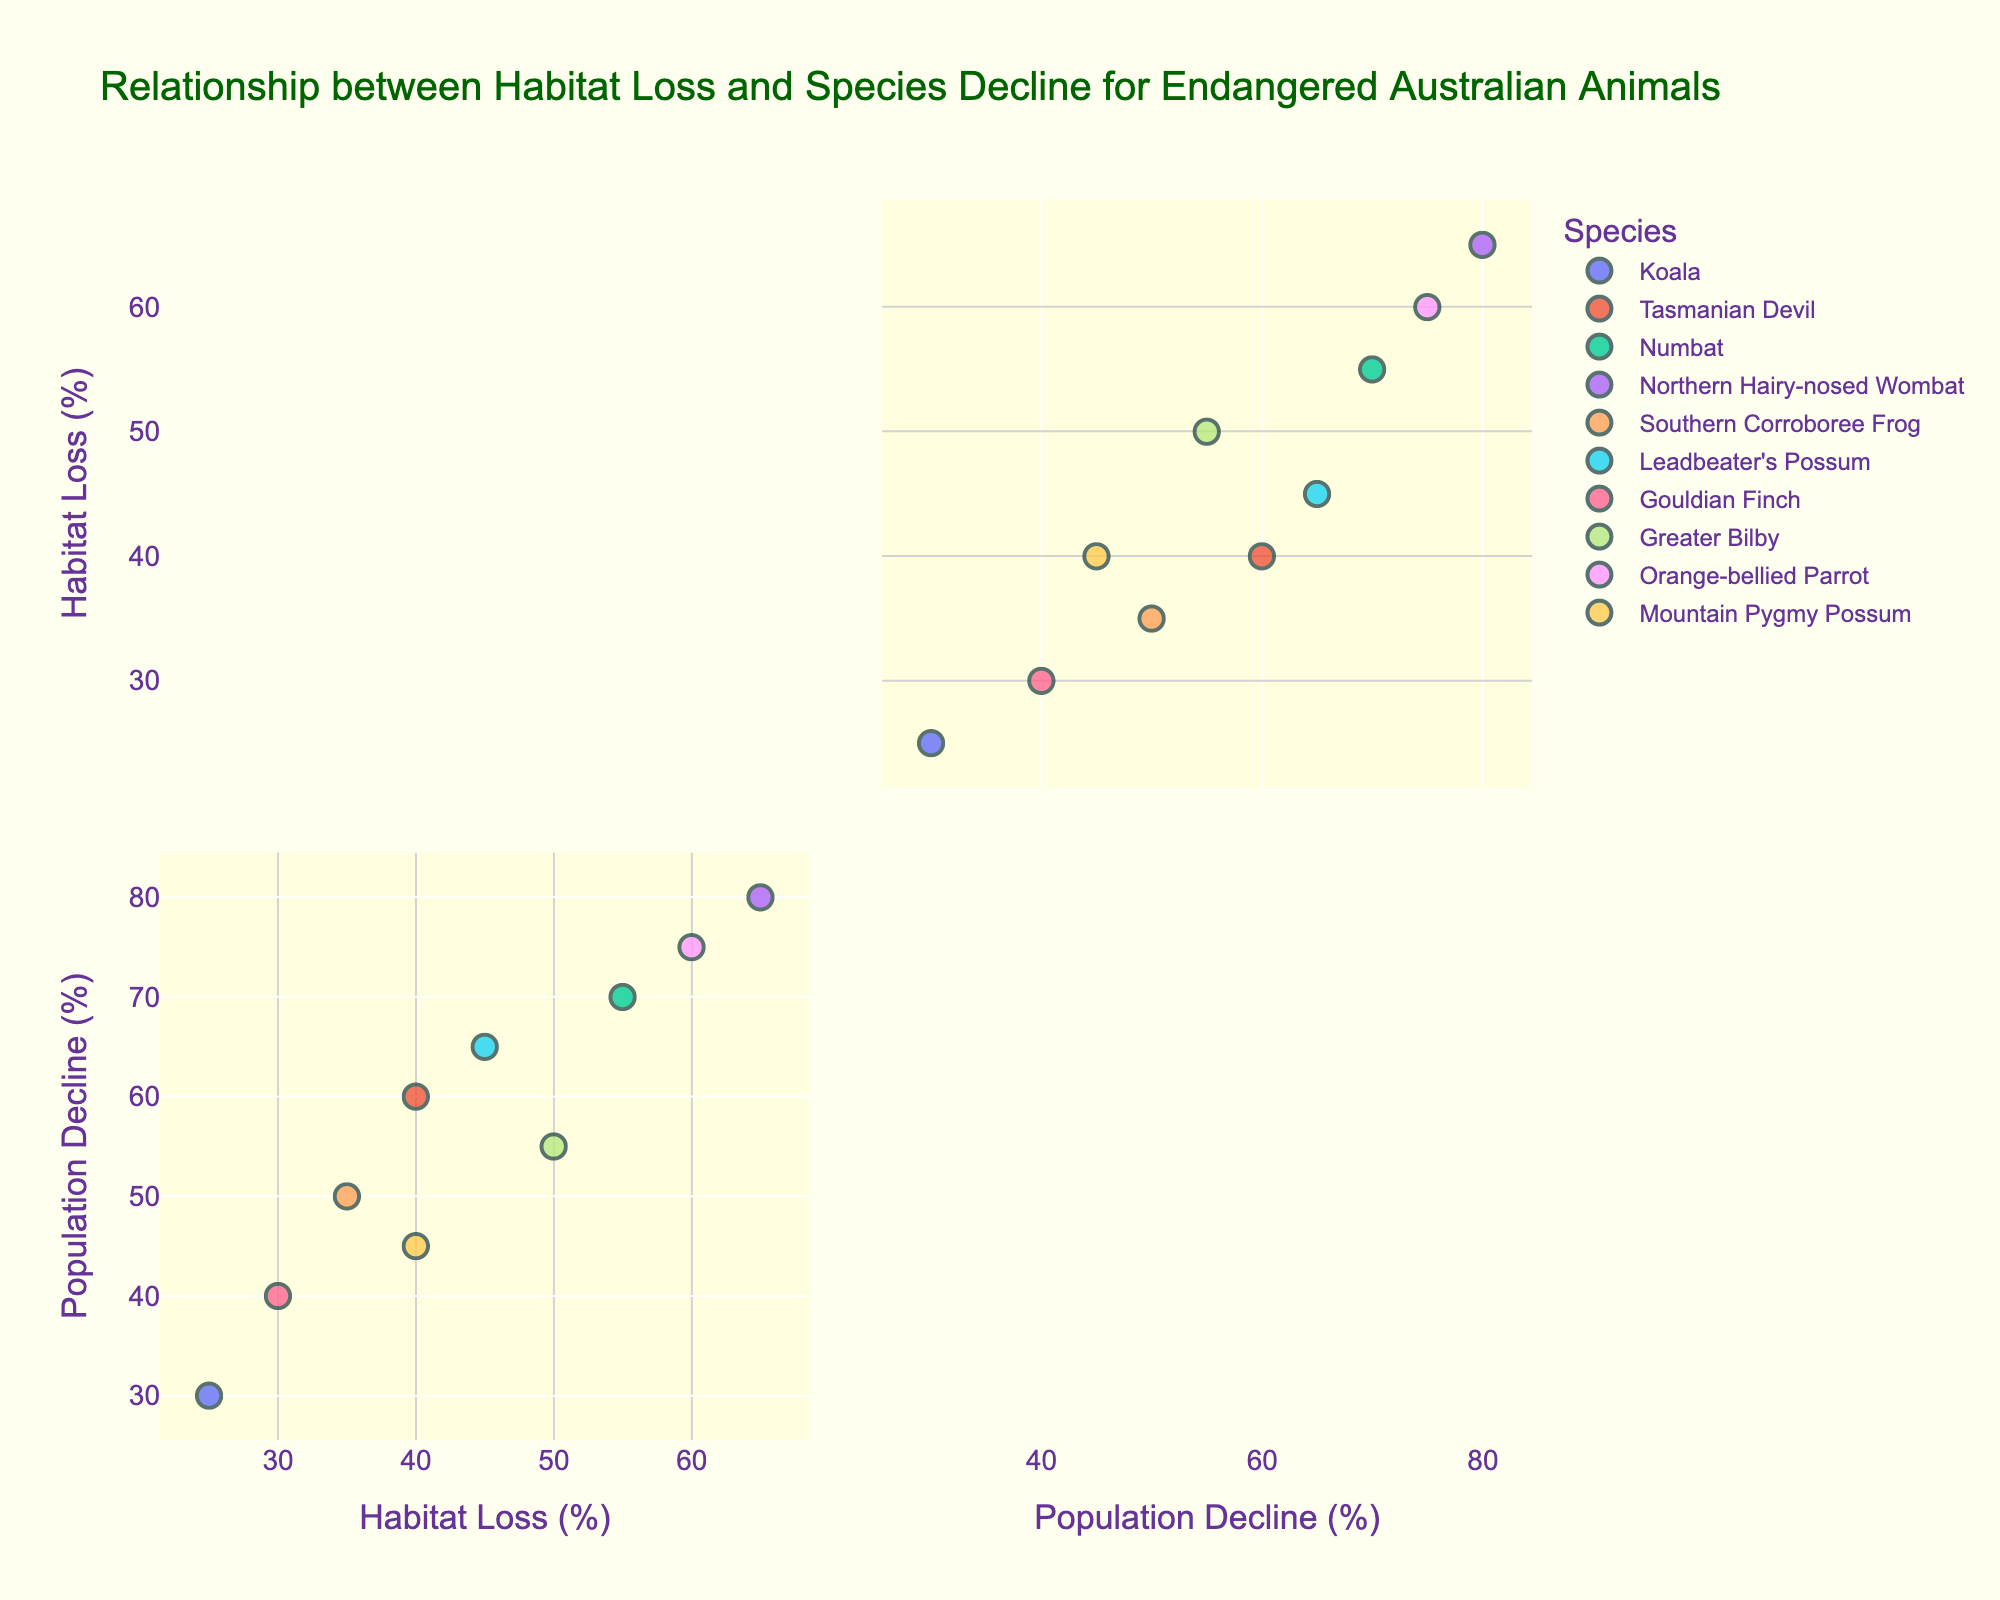What's the title of the scatterplot matrix? The title is usually displayed at the top of the figure. In this case, it reads "Relationship between Habitat Loss and Species Decline for Endangered Australian Animals."
Answer: Relationship between Habitat Loss and Species Decline for Endangered Australian Animals What are the axis labels in the scatterplot matrix? The axis labels can be found at the bottom and left of the scatterplot matrix. The x-axis label is "Habitat Loss (%)" and the y-axis label is "Population Decline (%)".
Answer: Habitat Loss (%) and Population Decline (%) How many species are represented in the scatterplot matrix? Each unique color represents a different species. By counting the unique colors in the legend, we see that there are 10 species.
Answer: 10 Which species shows the highest habitat loss percentage? Locate the species at the maximum point on the x-axis related to "Habitat Loss (%)". The Northern Hairy-nosed Wombat has the highest habitat loss percentage at 65%.
Answer: Northern Hairy-nosed Wombat Which species have a habitat loss percentage of 40%? Find the data points that align with 40% on the x-axis (Habitat Loss). The species with a habitat loss percentage of 40% are Mountain Pygmy Possum and Tasmanian Devil.
Answer: Mountain Pygmy Possum and Tasmanian Devil What is the average population decline percentage for species with habitat loss greater than 50%? Identify the species with habitat loss greater than 50%, and find their population decline percentages: Numbat (70%), Northern Hairy-nosed Wombat (80%), Orange-bellied Parrot (75%). Then, calculate the average: (70 + 80 + 75) / 3 = 75%.
Answer: 75% Which species shows a population decline percentage close to 50%? Look for points near the value of 50% on the y-axis (Population Decline). The Southern Corroboree Frog has a population decline percentage of 50%.
Answer: Southern Corroboree Frog Do most species show a correlation between habitat loss and population decline? By observing the scatterplot matrix, we can check if data points generally trend upwards to the right. It appears that most species show a positive correlation between habitat loss and population decline (higher habitat loss correlates with higher population decline).
Answer: Yes Which species have both habitat loss and population decline percentages below 40%? Locate species with points both below 40% on the x-axis and y-axis. The Gouldian Finch belongs in this category with 30% habitat loss and 40% population decline.
Answer: Gouldian Finch 